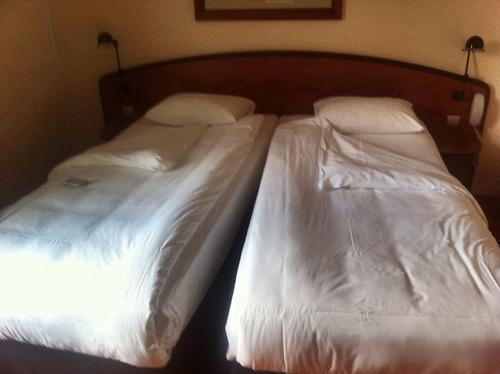What type of furniture can be seen in the image? Two twin size beds with wooden headboards, pillows, and comforters. List the objects placed on the left bed. A white pillow, a white comforter with wrinkles, and an unidentified object. Count the number of lamps in the image and describe their appearance. There are two small black bedside lamps on the wooden headboard. Is there any electronic device seen in the image? If yes, describe its appearance and location. Yes, a white bedside telephone with a cord is present on the wooden headboard. What is the color of the headboard, and what material is it made of? The headboard is brown and made of wood. How many beds are in the room, and what are their colors? There are two twin beds in the room, with white sheets and pillows. What color are the pillows on the beds? The pillows on the beds are white. Tell me about the artwork displayed in the image. There is a framed artwork hanging on the wall above the beds, featuring a brown picture frame. Mention objects placed on the headboard of the beds. There are small black bedside lamps and a white bedside telephone with a cord. Describe the appearance of the comforter on the bed. The comforter is white and has wrinkles; a portion of it is folded into a triangle shape. 